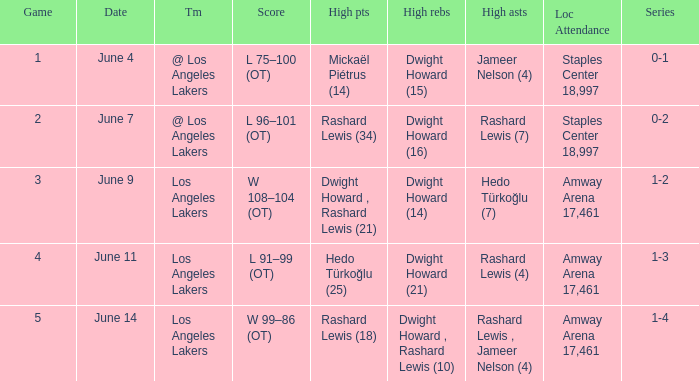What is Series, when Date is "June 7"? 0-2. 